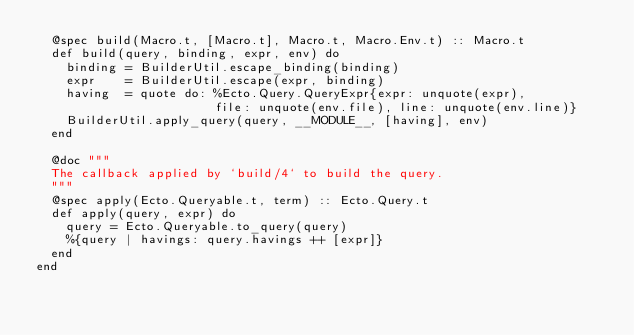Convert code to text. <code><loc_0><loc_0><loc_500><loc_500><_Elixir_>  @spec build(Macro.t, [Macro.t], Macro.t, Macro.Env.t) :: Macro.t
  def build(query, binding, expr, env) do
    binding = BuilderUtil.escape_binding(binding)
    expr    = BuilderUtil.escape(expr, binding)
    having  = quote do: %Ecto.Query.QueryExpr{expr: unquote(expr),
                        file: unquote(env.file), line: unquote(env.line)}
    BuilderUtil.apply_query(query, __MODULE__, [having], env)
  end

  @doc """
  The callback applied by `build/4` to build the query.
  """
  @spec apply(Ecto.Queryable.t, term) :: Ecto.Query.t
  def apply(query, expr) do
    query = Ecto.Queryable.to_query(query)
    %{query | havings: query.havings ++ [expr]}
  end
end
</code> 